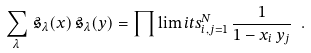Convert formula to latex. <formula><loc_0><loc_0><loc_500><loc_500>\sum _ { \lambda } \, \mathfrak { s } _ { \lambda } ( x ) \, \mathfrak { s } _ { \lambda } ( y ) = \prod \lim i t s _ { i , j = 1 } ^ { N } \, \frac { 1 } { 1 - x _ { i } \, y _ { j } } \ .</formula> 